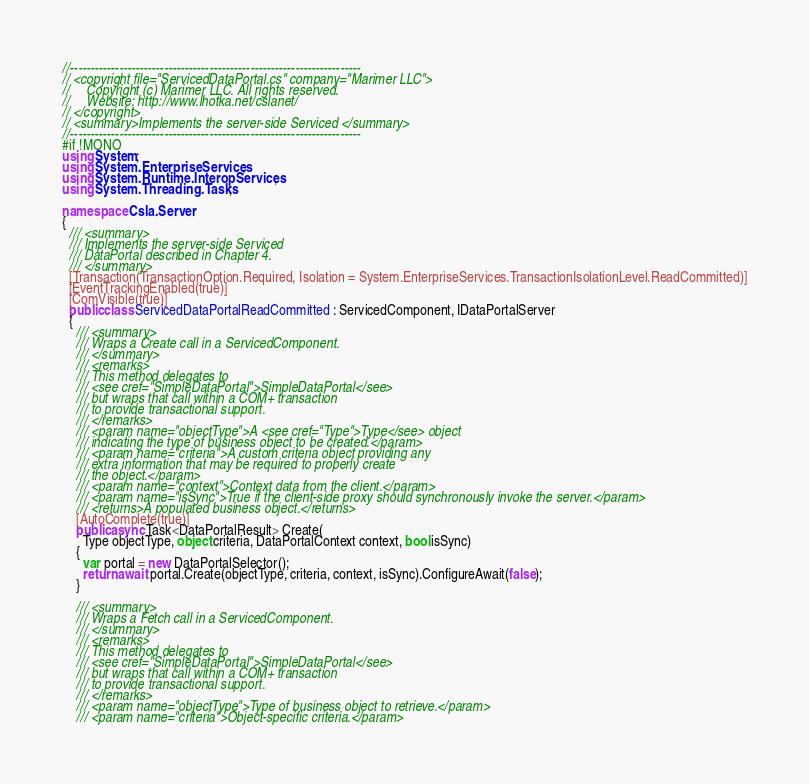<code> <loc_0><loc_0><loc_500><loc_500><_C#_>//-----------------------------------------------------------------------
// <copyright file="ServicedDataPortal.cs" company="Marimer LLC">
//     Copyright (c) Marimer LLC. All rights reserved.
//     Website: http://www.lhotka.net/cslanet/
// </copyright>
// <summary>Implements the server-side Serviced </summary>
//-----------------------------------------------------------------------
#if !MONO 
using System;
using System.EnterpriseServices;
using System.Runtime.InteropServices;
using System.Threading.Tasks;

namespace Csla.Server
{
  /// <summary>
  /// Implements the server-side Serviced 
  /// DataPortal described in Chapter 4.
  /// </summary>
  [Transaction(TransactionOption.Required, Isolation = System.EnterpriseServices.TransactionIsolationLevel.ReadCommitted)]
  [EventTrackingEnabled(true)]
  [ComVisible(true)]
  public class ServicedDataPortalReadCommitted : ServicedComponent, IDataPortalServer
  {
    /// <summary>
    /// Wraps a Create call in a ServicedComponent.
    /// </summary>
    /// <remarks>
    /// This method delegates to 
    /// <see cref="SimpleDataPortal">SimpleDataPortal</see>
    /// but wraps that call within a COM+ transaction
    /// to provide transactional support.
    /// </remarks>
    /// <param name="objectType">A <see cref="Type">Type</see> object
    /// indicating the type of business object to be created.</param>
    /// <param name="criteria">A custom criteria object providing any
    /// extra information that may be required to properly create
    /// the object.</param>
    /// <param name="context">Context data from the client.</param>
    /// <param name="isSync">True if the client-side proxy should synchronously invoke the server.</param>
    /// <returns>A populated business object.</returns>
    [AutoComplete(true)]
    public async Task<DataPortalResult> Create(
      Type objectType, object criteria, DataPortalContext context, bool isSync)
    {
      var portal = new DataPortalSelector();
      return await portal.Create(objectType, criteria, context, isSync).ConfigureAwait(false);
    }

    /// <summary>
    /// Wraps a Fetch call in a ServicedComponent.
    /// </summary>
    /// <remarks>
    /// This method delegates to 
    /// <see cref="SimpleDataPortal">SimpleDataPortal</see>
    /// but wraps that call within a COM+ transaction
    /// to provide transactional support.
    /// </remarks>
    /// <param name="objectType">Type of business object to retrieve.</param>
    /// <param name="criteria">Object-specific criteria.</param></code> 